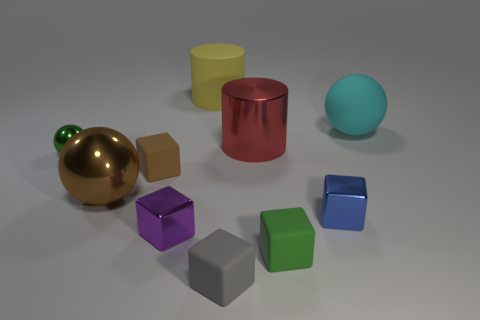Are the gray thing and the brown cube made of the same material?
Your answer should be compact. Yes. What is the size of the other metallic thing that is the same shape as the tiny purple shiny object?
Provide a succinct answer. Small. What number of objects are either large things that are in front of the rubber sphere or small cubes that are to the right of the large red metallic cylinder?
Make the answer very short. 4. Is the number of small blue metallic things less than the number of tiny cyan cylinders?
Make the answer very short. No. There is a green matte cube; does it have the same size as the rubber block behind the small purple metallic object?
Give a very brief answer. Yes. What number of matte objects are small green objects or big cyan things?
Provide a succinct answer. 2. Are there more small gray objects than matte blocks?
Your answer should be compact. No. There is a thing that is the same color as the tiny ball; what is its size?
Provide a short and direct response. Small. The matte thing on the left side of the rubber object that is behind the cyan object is what shape?
Give a very brief answer. Cube. Is there a thing that is to the left of the metallic ball that is in front of the block on the left side of the purple object?
Your answer should be compact. Yes. 